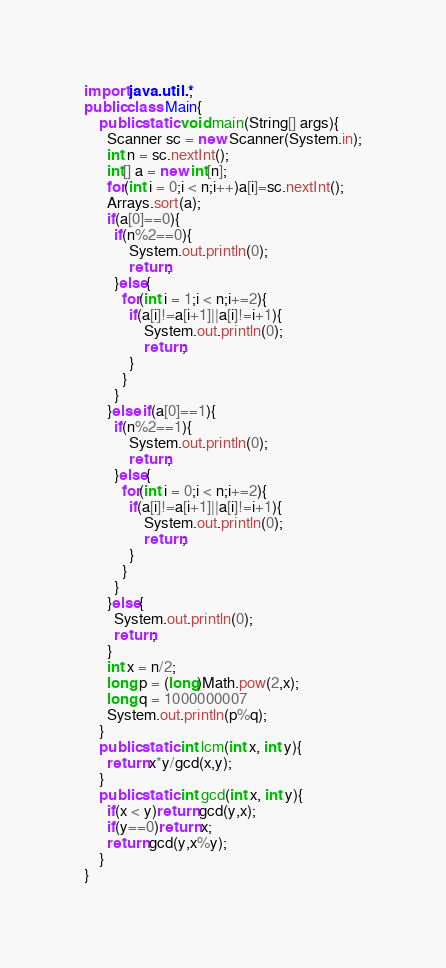Convert code to text. <code><loc_0><loc_0><loc_500><loc_500><_Java_>import java.util.*;
public class Main{   
    public static void main(String[] args){
      Scanner sc = new Scanner(System.in);
      int n = sc.nextInt();
      int[] a = new int[n];
      for(int i = 0;i < n;i++)a[i]=sc.nextInt();
      Arrays.sort(a);
      if(a[0]==0){
        if(n%2==0){
        	System.out.println(0);
            return;
        }else{
          for(int i = 1;i < n;i+=2){
          	if(a[i]!=a[i+1]||a[i]!=i+1){
          		System.out.println(0);
            	return;
          	}
      	  }
        }
      }else if(a[0]==1){
      	if(n%2==1){
        	System.out.println(0);
            return;
        }else{
          for(int i = 0;i < n;i+=2){
          	if(a[i]!=a[i+1]||a[i]!=i+1){
            	System.out.println(0);
                return;
            }
          }
        }
      }else{
      	System.out.println(0);
        return;
      }
      int x = n/2;
      long p = (long)Math.pow(2,x);
      long q = 1000000007
      System.out.println(p%q);
    }
    public static int lcm(int x, int y){
      return x*y/gcd(x,y);
    }
    public static int gcd(int x, int y){
      if(x < y)return gcd(y,x);
      if(y==0)return x;
      return gcd(y,x%y);
    }
}
</code> 